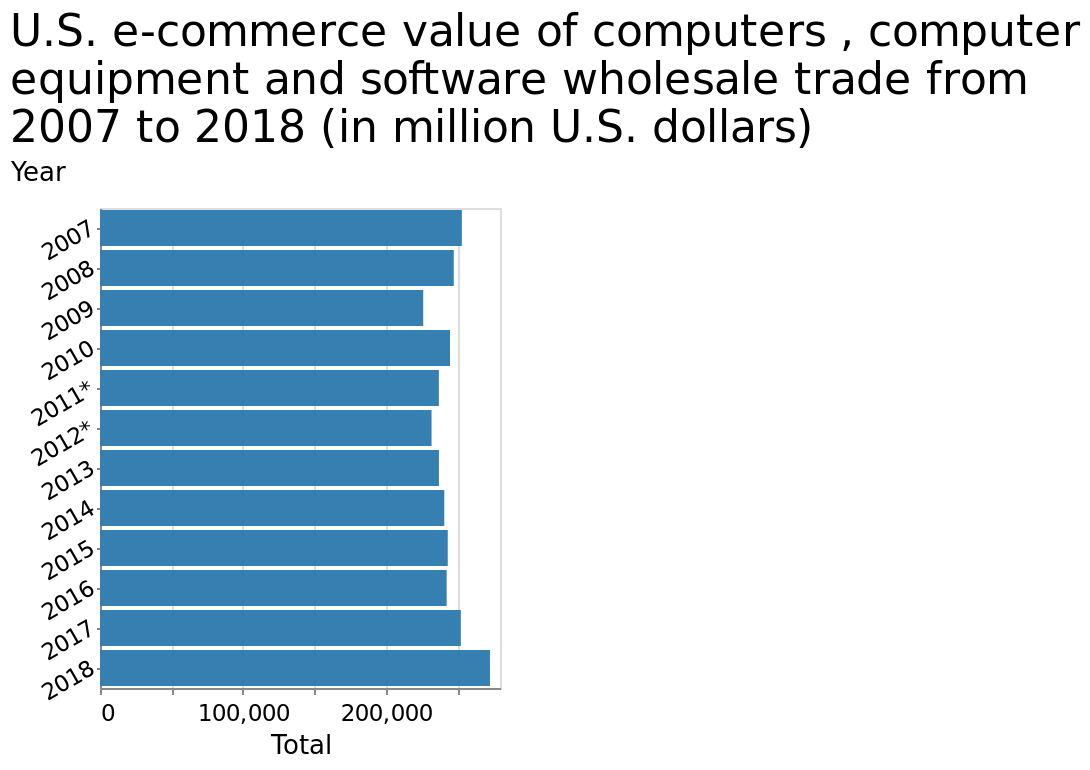<image>
Describe the following image in detail Here a bar diagram is labeled U.S. e-commerce value of computers , computer equipment and software wholesale trade from 2007 to 2018 (in million U.S. dollars). Total is measured as a linear scale from 0 to 250,000 on the x-axis. Along the y-axis, Year is plotted. 